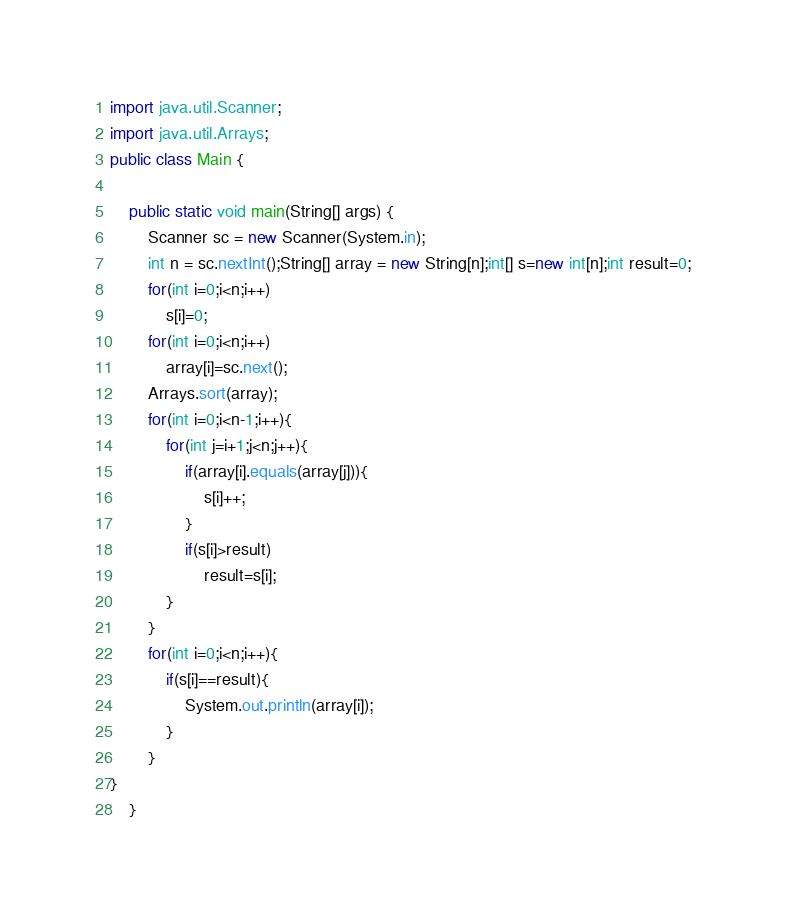<code> <loc_0><loc_0><loc_500><loc_500><_Java_>import java.util.Scanner;
import java.util.Arrays;
public class Main {

    public static void main(String[] args) {
        Scanner sc = new Scanner(System.in);
        int n = sc.nextInt();String[] array = new String[n];int[] s=new int[n];int result=0;
        for(int i=0;i<n;i++)
            s[i]=0;
        for(int i=0;i<n;i++)
            array[i]=sc.next();
        Arrays.sort(array);
        for(int i=0;i<n-1;i++){
            for(int j=i+1;j<n;j++){
                if(array[i].equals(array[j])){
                    s[i]++;
                }
                if(s[i]>result)
                    result=s[i];
            }
        }
        for(int i=0;i<n;i++){
            if(s[i]==result){
                System.out.println(array[i]);
            }
        }
}
    }</code> 